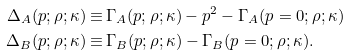<formula> <loc_0><loc_0><loc_500><loc_500>\Delta _ { A } ( p ; \rho ; \kappa ) \equiv & \, \Gamma _ { A } ( p ; \rho ; \kappa ) - p ^ { 2 } - \Gamma _ { A } ( p = 0 ; \rho ; \kappa ) \\ \Delta _ { B } ( p ; \rho ; \kappa ) \equiv & \, \Gamma _ { B } ( p ; \rho ; \kappa ) - \Gamma _ { B } ( p = 0 ; \rho ; \kappa ) .</formula> 